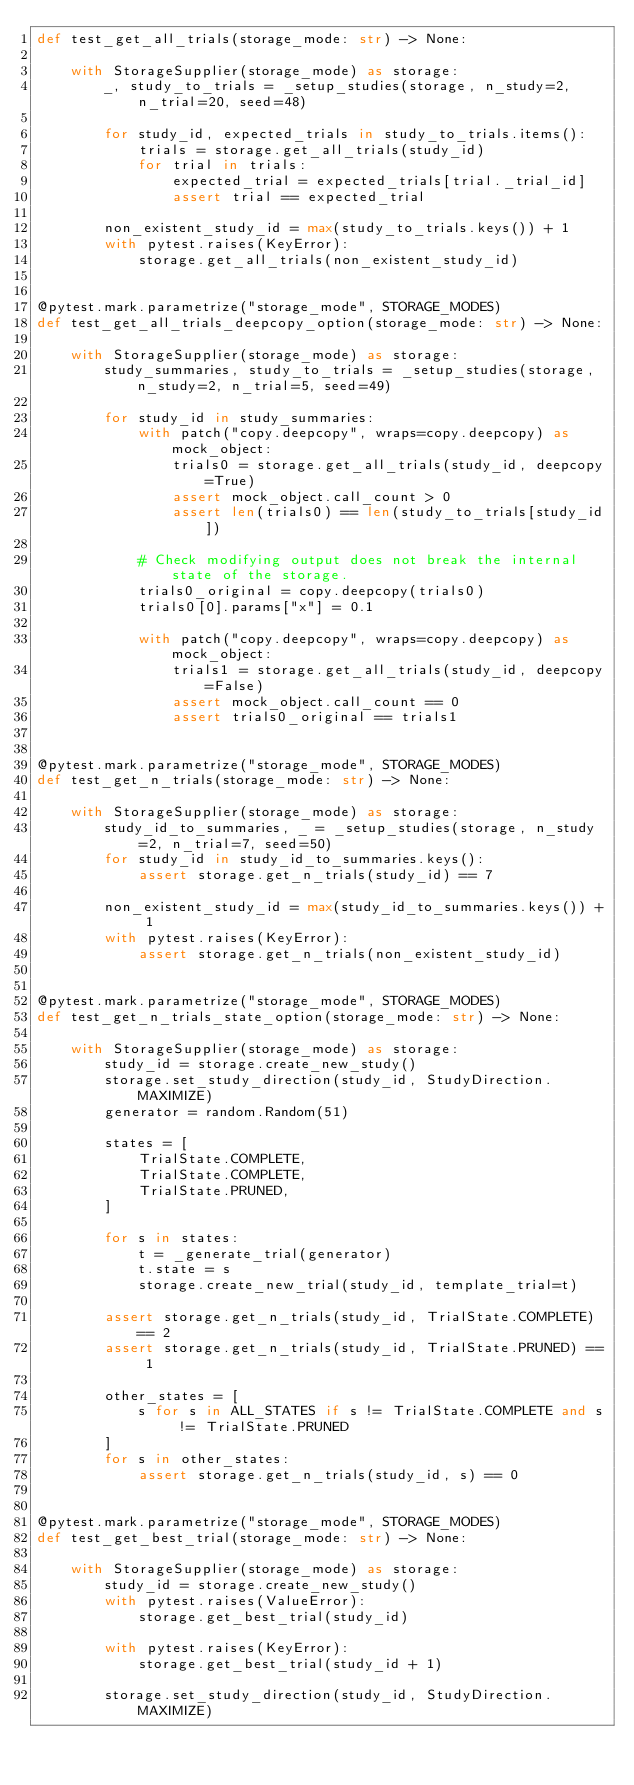<code> <loc_0><loc_0><loc_500><loc_500><_Python_>def test_get_all_trials(storage_mode: str) -> None:

    with StorageSupplier(storage_mode) as storage:
        _, study_to_trials = _setup_studies(storage, n_study=2, n_trial=20, seed=48)

        for study_id, expected_trials in study_to_trials.items():
            trials = storage.get_all_trials(study_id)
            for trial in trials:
                expected_trial = expected_trials[trial._trial_id]
                assert trial == expected_trial

        non_existent_study_id = max(study_to_trials.keys()) + 1
        with pytest.raises(KeyError):
            storage.get_all_trials(non_existent_study_id)


@pytest.mark.parametrize("storage_mode", STORAGE_MODES)
def test_get_all_trials_deepcopy_option(storage_mode: str) -> None:

    with StorageSupplier(storage_mode) as storage:
        study_summaries, study_to_trials = _setup_studies(storage, n_study=2, n_trial=5, seed=49)

        for study_id in study_summaries:
            with patch("copy.deepcopy", wraps=copy.deepcopy) as mock_object:
                trials0 = storage.get_all_trials(study_id, deepcopy=True)
                assert mock_object.call_count > 0
                assert len(trials0) == len(study_to_trials[study_id])

            # Check modifying output does not break the internal state of the storage.
            trials0_original = copy.deepcopy(trials0)
            trials0[0].params["x"] = 0.1

            with patch("copy.deepcopy", wraps=copy.deepcopy) as mock_object:
                trials1 = storage.get_all_trials(study_id, deepcopy=False)
                assert mock_object.call_count == 0
                assert trials0_original == trials1


@pytest.mark.parametrize("storage_mode", STORAGE_MODES)
def test_get_n_trials(storage_mode: str) -> None:

    with StorageSupplier(storage_mode) as storage:
        study_id_to_summaries, _ = _setup_studies(storage, n_study=2, n_trial=7, seed=50)
        for study_id in study_id_to_summaries.keys():
            assert storage.get_n_trials(study_id) == 7

        non_existent_study_id = max(study_id_to_summaries.keys()) + 1
        with pytest.raises(KeyError):
            assert storage.get_n_trials(non_existent_study_id)


@pytest.mark.parametrize("storage_mode", STORAGE_MODES)
def test_get_n_trials_state_option(storage_mode: str) -> None:

    with StorageSupplier(storage_mode) as storage:
        study_id = storage.create_new_study()
        storage.set_study_direction(study_id, StudyDirection.MAXIMIZE)
        generator = random.Random(51)

        states = [
            TrialState.COMPLETE,
            TrialState.COMPLETE,
            TrialState.PRUNED,
        ]

        for s in states:
            t = _generate_trial(generator)
            t.state = s
            storage.create_new_trial(study_id, template_trial=t)

        assert storage.get_n_trials(study_id, TrialState.COMPLETE) == 2
        assert storage.get_n_trials(study_id, TrialState.PRUNED) == 1

        other_states = [
            s for s in ALL_STATES if s != TrialState.COMPLETE and s != TrialState.PRUNED
        ]
        for s in other_states:
            assert storage.get_n_trials(study_id, s) == 0


@pytest.mark.parametrize("storage_mode", STORAGE_MODES)
def test_get_best_trial(storage_mode: str) -> None:

    with StorageSupplier(storage_mode) as storage:
        study_id = storage.create_new_study()
        with pytest.raises(ValueError):
            storage.get_best_trial(study_id)

        with pytest.raises(KeyError):
            storage.get_best_trial(study_id + 1)

        storage.set_study_direction(study_id, StudyDirection.MAXIMIZE)</code> 